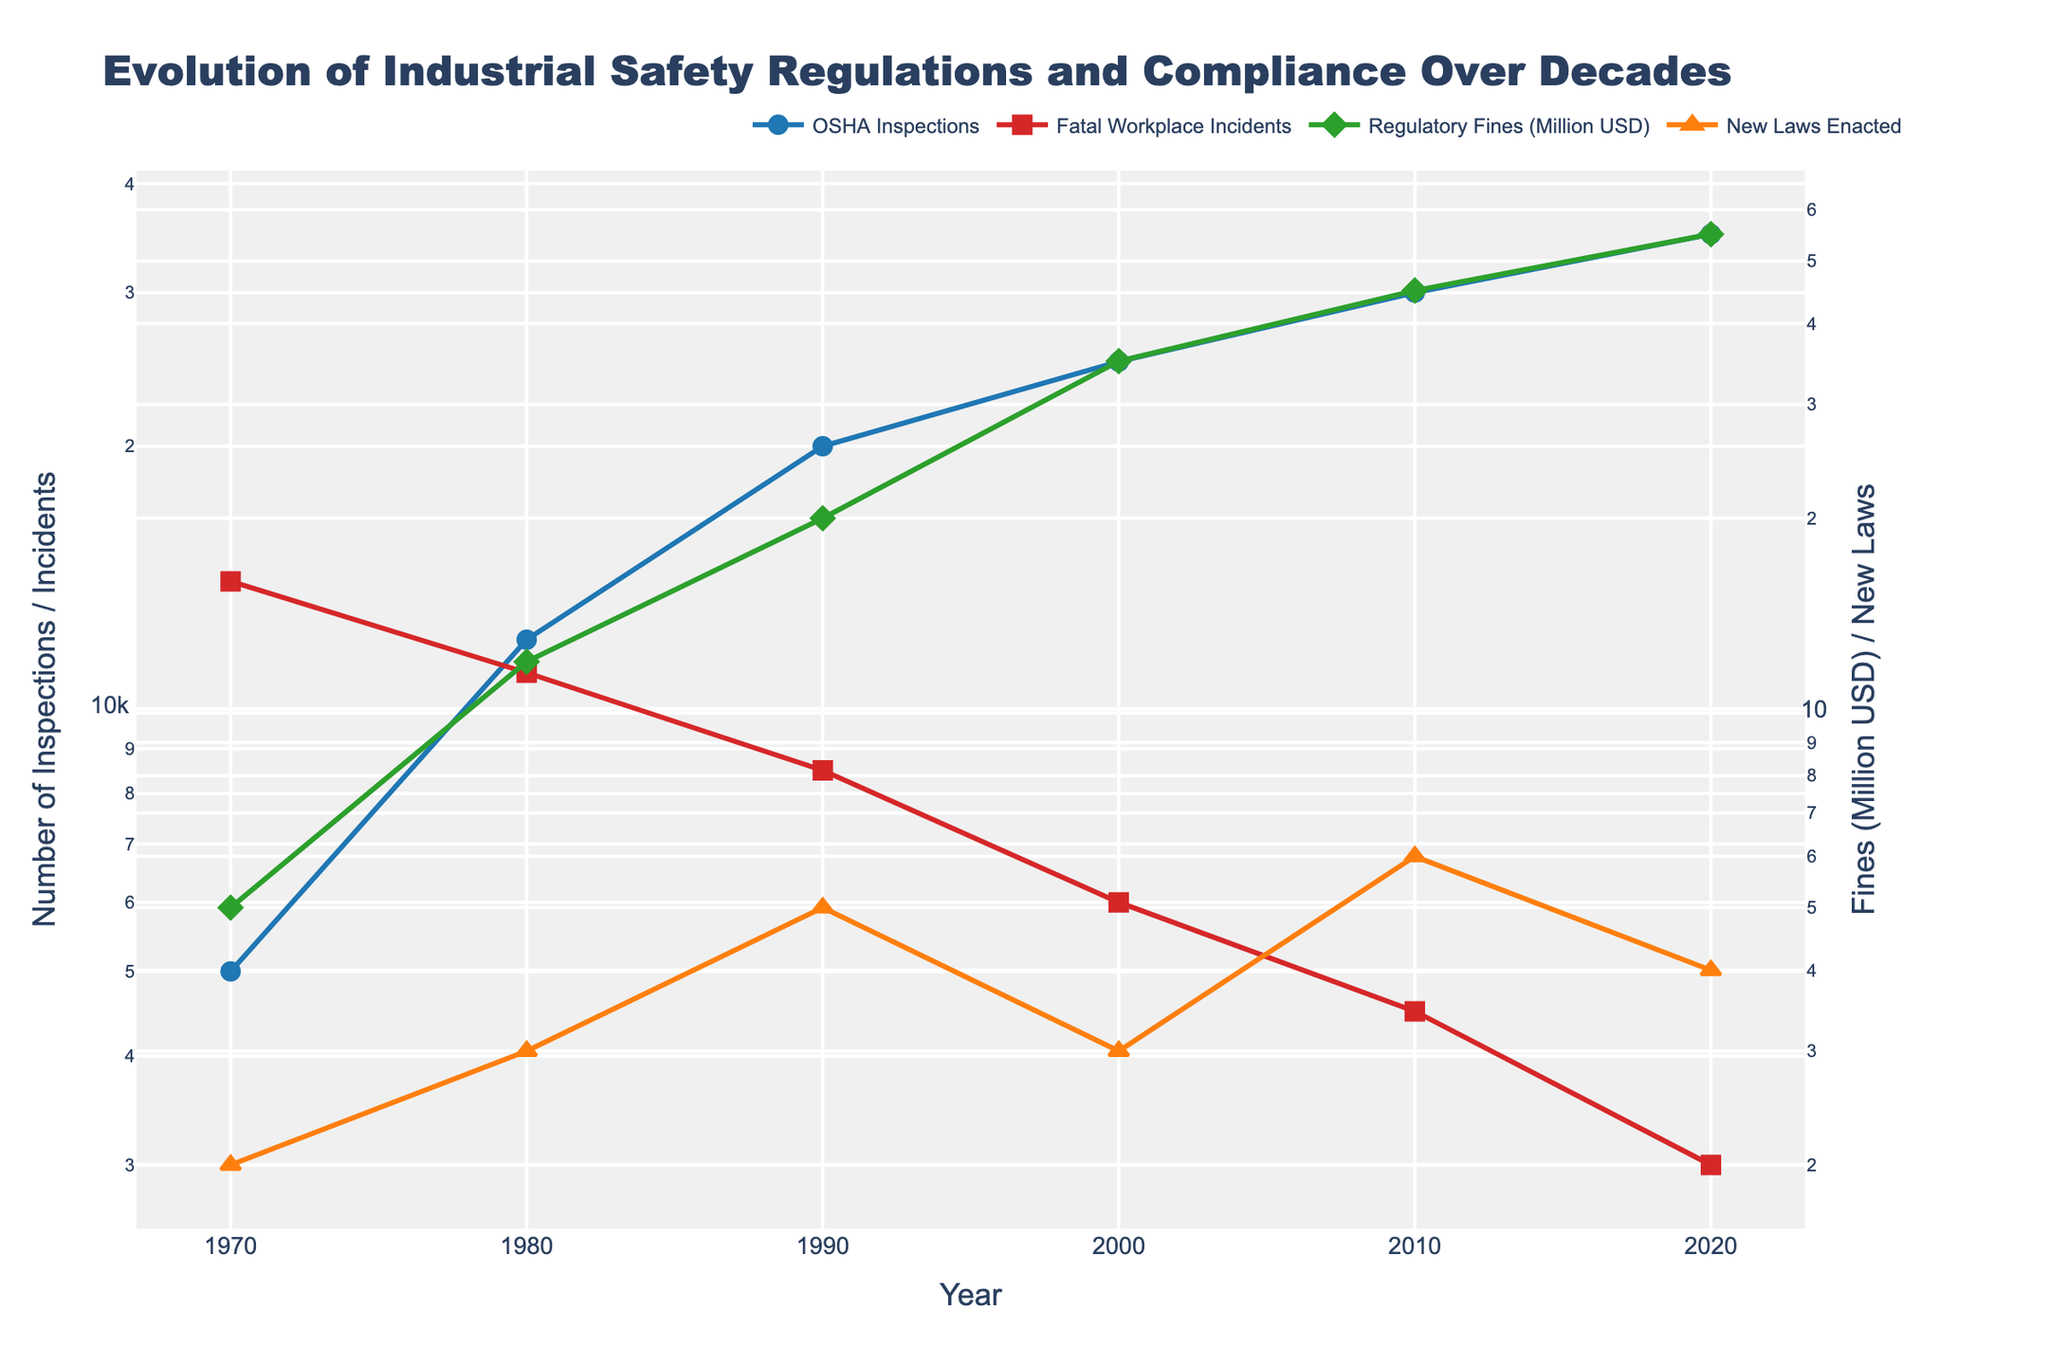What is the title of the plot? The title is located at the top of the plot and provides a high-level summary of what the figure represents.
Answer: Evolution of Industrial Safety Regulations and Compliance Over Decades How many years of data are displayed in the plot? The x-axis of the plot represents the years, which can be counted.
Answer: 6 Which year had the highest number of OSHA inspections? To find this, look at the line representing 'OSHA Inspections' and determine the peak.
Answer: 2020 How many new laws were enacted in the year 2010? Locate the point in the 'New Laws Enacted' series corresponding to 2010.
Answer: 6 In which decade did fatal workplace incidents see the most significant decrease? Examine the trend of the 'Fatal Workplace Incidents' line and identify the decade where the decrease is the most pronounced.
Answer: 1970s to 1980s What is the trend for Regulatory Fines (Million USD) over the decades? Analyze the line representing 'Regulatory Fines (Million USD)' for its general direction and pattern.
Answer: Increasing Which two metrics use the secondary y-axis? Check the axis on the right side of the plot and see which lines it aligns with.
Answer: Regulatory Fines (Million USD) and New Laws Enacted How does the trend in OSHA inspections compare with fatal workplace incidents over time? To answer this, compare the lines for 'OSHA Inspections' and 'Fatal Workplace Incidents.'
Answer: OSHA inspections increase, while fatal workplace incidents decrease What is the color used to represent Fatal Workplace Incidents? Look at the legend or the line itself to determine its color.
Answer: Red Between 2000 and 2010, by how much did regulatory fines increase? Subtract the value of regulatory fines in 2000 from the value in 2010.
Answer: 25 Million USD 